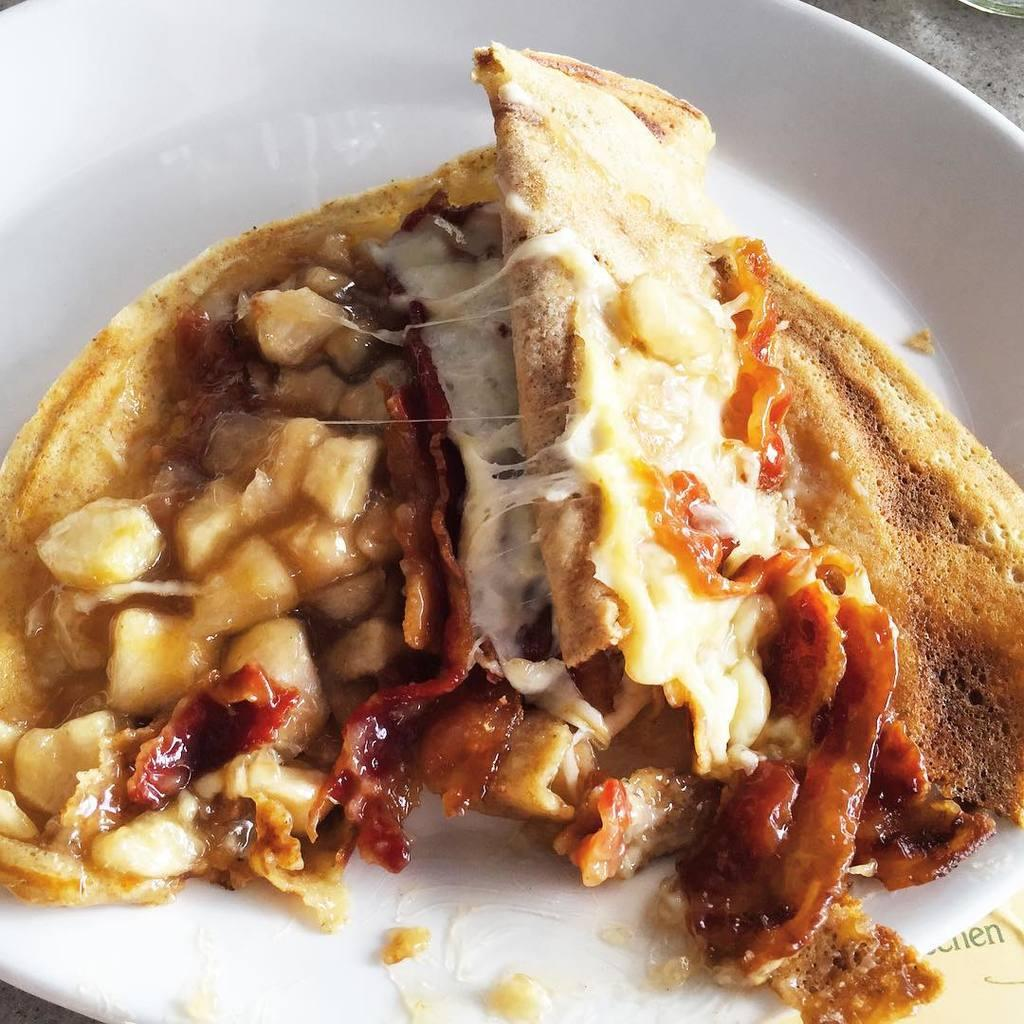What is the main subject of the image? There is a food item in the image. How is the food item presented in the image? The food item is on a white color plate. Where is the plate located in the image? The plate is in the middle of the image. How many snakes are slithering around the plate in the image? There are no snakes present in the image; it only features a food item on a white plate. What type of sign can be seen in the image? There is no sign present in the image. 